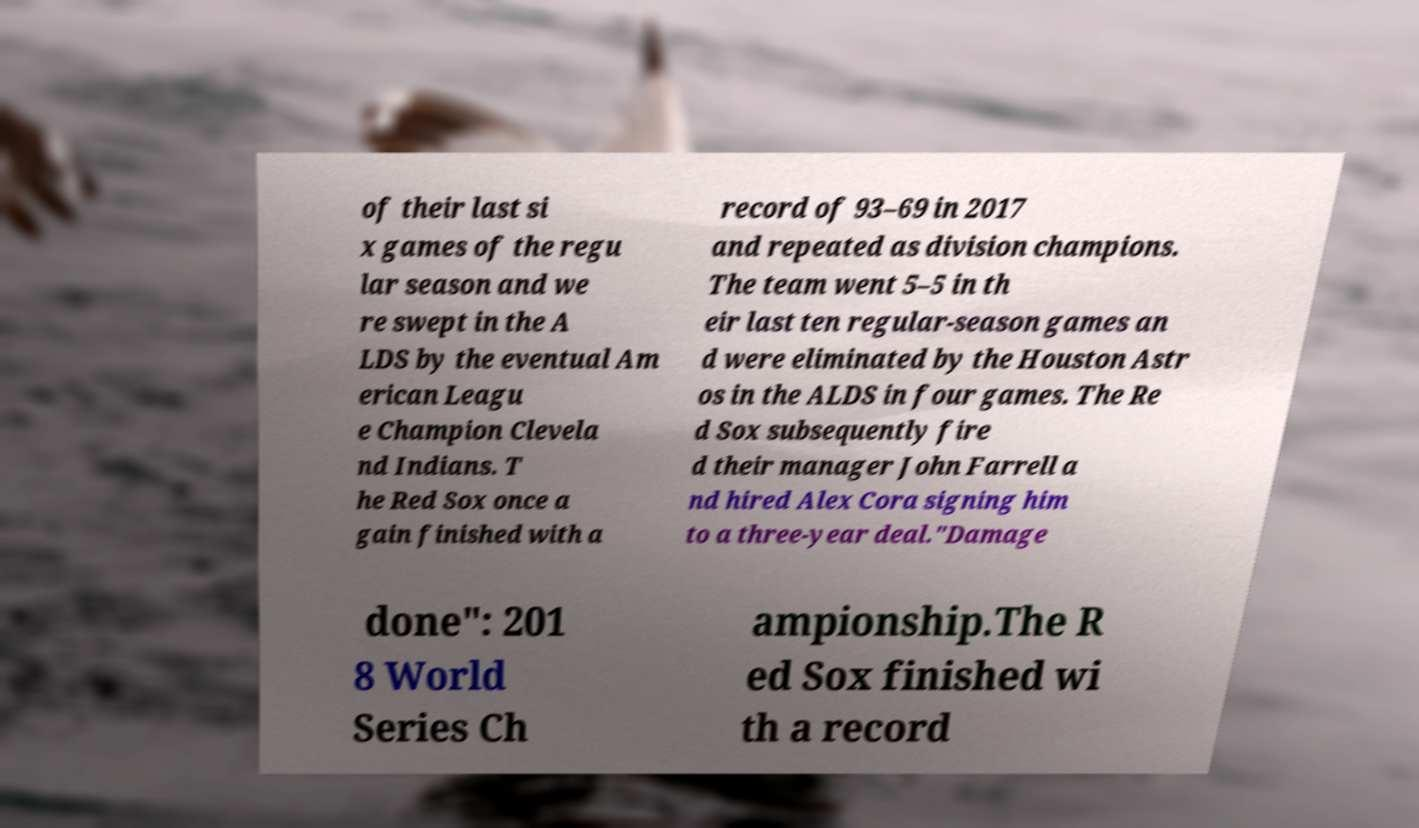Can you read and provide the text displayed in the image?This photo seems to have some interesting text. Can you extract and type it out for me? of their last si x games of the regu lar season and we re swept in the A LDS by the eventual Am erican Leagu e Champion Clevela nd Indians. T he Red Sox once a gain finished with a record of 93–69 in 2017 and repeated as division champions. The team went 5–5 in th eir last ten regular-season games an d were eliminated by the Houston Astr os in the ALDS in four games. The Re d Sox subsequently fire d their manager John Farrell a nd hired Alex Cora signing him to a three-year deal."Damage done": 201 8 World Series Ch ampionship.The R ed Sox finished wi th a record 